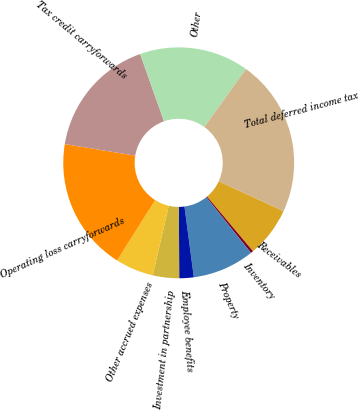<chart> <loc_0><loc_0><loc_500><loc_500><pie_chart><fcel>Receivables<fcel>Inventory<fcel>Property<fcel>Employee benefits<fcel>Investment in partnership<fcel>Other accrued expenses<fcel>Operating loss carryforwards<fcel>Tax credit carryforwards<fcel>Other<fcel>Total deferred income tax<nl><fcel>7.01%<fcel>0.36%<fcel>8.67%<fcel>2.02%<fcel>3.68%<fcel>5.35%<fcel>18.64%<fcel>16.98%<fcel>15.32%<fcel>21.97%<nl></chart> 